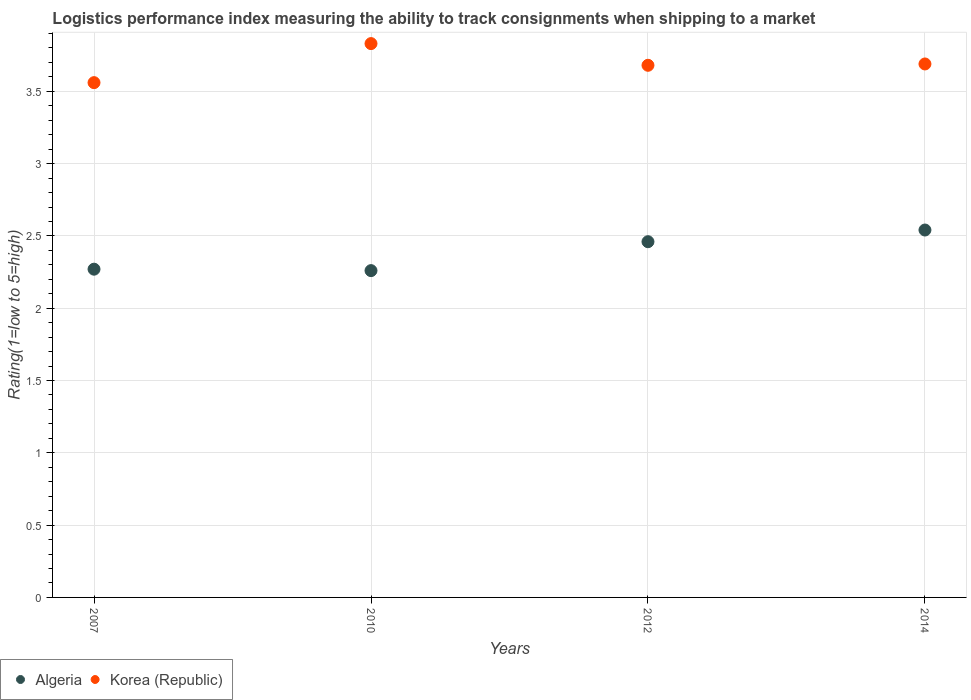Is the number of dotlines equal to the number of legend labels?
Provide a short and direct response. Yes. What is the Logistic performance index in Algeria in 2014?
Make the answer very short. 2.54. Across all years, what is the maximum Logistic performance index in Algeria?
Ensure brevity in your answer.  2.54. Across all years, what is the minimum Logistic performance index in Korea (Republic)?
Your answer should be very brief. 3.56. In which year was the Logistic performance index in Algeria maximum?
Your response must be concise. 2014. What is the total Logistic performance index in Algeria in the graph?
Ensure brevity in your answer.  9.53. What is the difference between the Logistic performance index in Korea (Republic) in 2007 and that in 2010?
Ensure brevity in your answer.  -0.27. What is the difference between the Logistic performance index in Algeria in 2014 and the Logistic performance index in Korea (Republic) in 2007?
Your answer should be compact. -1.02. What is the average Logistic performance index in Korea (Republic) per year?
Keep it short and to the point. 3.69. In the year 2007, what is the difference between the Logistic performance index in Algeria and Logistic performance index in Korea (Republic)?
Offer a very short reply. -1.29. What is the ratio of the Logistic performance index in Algeria in 2007 to that in 2014?
Keep it short and to the point. 0.89. What is the difference between the highest and the second highest Logistic performance index in Algeria?
Provide a succinct answer. 0.08. What is the difference between the highest and the lowest Logistic performance index in Korea (Republic)?
Your response must be concise. 0.27. Is the sum of the Logistic performance index in Korea (Republic) in 2012 and 2014 greater than the maximum Logistic performance index in Algeria across all years?
Keep it short and to the point. Yes. How many dotlines are there?
Offer a very short reply. 2. What is the difference between two consecutive major ticks on the Y-axis?
Provide a short and direct response. 0.5. Does the graph contain grids?
Ensure brevity in your answer.  Yes. Where does the legend appear in the graph?
Your answer should be compact. Bottom left. How are the legend labels stacked?
Ensure brevity in your answer.  Horizontal. What is the title of the graph?
Your answer should be very brief. Logistics performance index measuring the ability to track consignments when shipping to a market. Does "French Polynesia" appear as one of the legend labels in the graph?
Make the answer very short. No. What is the label or title of the Y-axis?
Provide a short and direct response. Rating(1=low to 5=high). What is the Rating(1=low to 5=high) in Algeria in 2007?
Your answer should be compact. 2.27. What is the Rating(1=low to 5=high) of Korea (Republic) in 2007?
Offer a terse response. 3.56. What is the Rating(1=low to 5=high) of Algeria in 2010?
Give a very brief answer. 2.26. What is the Rating(1=low to 5=high) of Korea (Republic) in 2010?
Ensure brevity in your answer.  3.83. What is the Rating(1=low to 5=high) of Algeria in 2012?
Give a very brief answer. 2.46. What is the Rating(1=low to 5=high) of Korea (Republic) in 2012?
Provide a short and direct response. 3.68. What is the Rating(1=low to 5=high) in Algeria in 2014?
Provide a succinct answer. 2.54. What is the Rating(1=low to 5=high) of Korea (Republic) in 2014?
Keep it short and to the point. 3.69. Across all years, what is the maximum Rating(1=low to 5=high) of Algeria?
Offer a terse response. 2.54. Across all years, what is the maximum Rating(1=low to 5=high) of Korea (Republic)?
Make the answer very short. 3.83. Across all years, what is the minimum Rating(1=low to 5=high) of Algeria?
Keep it short and to the point. 2.26. Across all years, what is the minimum Rating(1=low to 5=high) of Korea (Republic)?
Provide a short and direct response. 3.56. What is the total Rating(1=low to 5=high) in Algeria in the graph?
Offer a very short reply. 9.53. What is the total Rating(1=low to 5=high) of Korea (Republic) in the graph?
Your answer should be compact. 14.76. What is the difference between the Rating(1=low to 5=high) of Korea (Republic) in 2007 and that in 2010?
Make the answer very short. -0.27. What is the difference between the Rating(1=low to 5=high) of Algeria in 2007 and that in 2012?
Provide a short and direct response. -0.19. What is the difference between the Rating(1=low to 5=high) of Korea (Republic) in 2007 and that in 2012?
Your answer should be very brief. -0.12. What is the difference between the Rating(1=low to 5=high) of Algeria in 2007 and that in 2014?
Offer a very short reply. -0.27. What is the difference between the Rating(1=low to 5=high) in Korea (Republic) in 2007 and that in 2014?
Offer a terse response. -0.13. What is the difference between the Rating(1=low to 5=high) in Algeria in 2010 and that in 2012?
Ensure brevity in your answer.  -0.2. What is the difference between the Rating(1=low to 5=high) in Algeria in 2010 and that in 2014?
Provide a succinct answer. -0.28. What is the difference between the Rating(1=low to 5=high) of Korea (Republic) in 2010 and that in 2014?
Keep it short and to the point. 0.14. What is the difference between the Rating(1=low to 5=high) of Algeria in 2012 and that in 2014?
Provide a succinct answer. -0.08. What is the difference between the Rating(1=low to 5=high) in Korea (Republic) in 2012 and that in 2014?
Offer a terse response. -0.01. What is the difference between the Rating(1=low to 5=high) of Algeria in 2007 and the Rating(1=low to 5=high) of Korea (Republic) in 2010?
Give a very brief answer. -1.56. What is the difference between the Rating(1=low to 5=high) of Algeria in 2007 and the Rating(1=low to 5=high) of Korea (Republic) in 2012?
Provide a short and direct response. -1.41. What is the difference between the Rating(1=low to 5=high) in Algeria in 2007 and the Rating(1=low to 5=high) in Korea (Republic) in 2014?
Provide a short and direct response. -1.42. What is the difference between the Rating(1=low to 5=high) in Algeria in 2010 and the Rating(1=low to 5=high) in Korea (Republic) in 2012?
Your answer should be very brief. -1.42. What is the difference between the Rating(1=low to 5=high) of Algeria in 2010 and the Rating(1=low to 5=high) of Korea (Republic) in 2014?
Make the answer very short. -1.43. What is the difference between the Rating(1=low to 5=high) of Algeria in 2012 and the Rating(1=low to 5=high) of Korea (Republic) in 2014?
Provide a succinct answer. -1.23. What is the average Rating(1=low to 5=high) of Algeria per year?
Your response must be concise. 2.38. What is the average Rating(1=low to 5=high) in Korea (Republic) per year?
Keep it short and to the point. 3.69. In the year 2007, what is the difference between the Rating(1=low to 5=high) of Algeria and Rating(1=low to 5=high) of Korea (Republic)?
Offer a terse response. -1.29. In the year 2010, what is the difference between the Rating(1=low to 5=high) of Algeria and Rating(1=low to 5=high) of Korea (Republic)?
Your answer should be very brief. -1.57. In the year 2012, what is the difference between the Rating(1=low to 5=high) in Algeria and Rating(1=low to 5=high) in Korea (Republic)?
Provide a short and direct response. -1.22. In the year 2014, what is the difference between the Rating(1=low to 5=high) in Algeria and Rating(1=low to 5=high) in Korea (Republic)?
Keep it short and to the point. -1.15. What is the ratio of the Rating(1=low to 5=high) in Algeria in 2007 to that in 2010?
Give a very brief answer. 1. What is the ratio of the Rating(1=low to 5=high) of Korea (Republic) in 2007 to that in 2010?
Make the answer very short. 0.93. What is the ratio of the Rating(1=low to 5=high) of Algeria in 2007 to that in 2012?
Provide a short and direct response. 0.92. What is the ratio of the Rating(1=low to 5=high) in Korea (Republic) in 2007 to that in 2012?
Make the answer very short. 0.97. What is the ratio of the Rating(1=low to 5=high) in Algeria in 2007 to that in 2014?
Provide a succinct answer. 0.89. What is the ratio of the Rating(1=low to 5=high) of Korea (Republic) in 2007 to that in 2014?
Offer a very short reply. 0.96. What is the ratio of the Rating(1=low to 5=high) in Algeria in 2010 to that in 2012?
Offer a very short reply. 0.92. What is the ratio of the Rating(1=low to 5=high) of Korea (Republic) in 2010 to that in 2012?
Ensure brevity in your answer.  1.04. What is the ratio of the Rating(1=low to 5=high) of Algeria in 2010 to that in 2014?
Your answer should be very brief. 0.89. What is the ratio of the Rating(1=low to 5=high) of Korea (Republic) in 2010 to that in 2014?
Keep it short and to the point. 1.04. What is the ratio of the Rating(1=low to 5=high) of Algeria in 2012 to that in 2014?
Provide a short and direct response. 0.97. What is the difference between the highest and the second highest Rating(1=low to 5=high) in Algeria?
Offer a terse response. 0.08. What is the difference between the highest and the second highest Rating(1=low to 5=high) of Korea (Republic)?
Offer a terse response. 0.14. What is the difference between the highest and the lowest Rating(1=low to 5=high) of Algeria?
Give a very brief answer. 0.28. What is the difference between the highest and the lowest Rating(1=low to 5=high) of Korea (Republic)?
Offer a terse response. 0.27. 